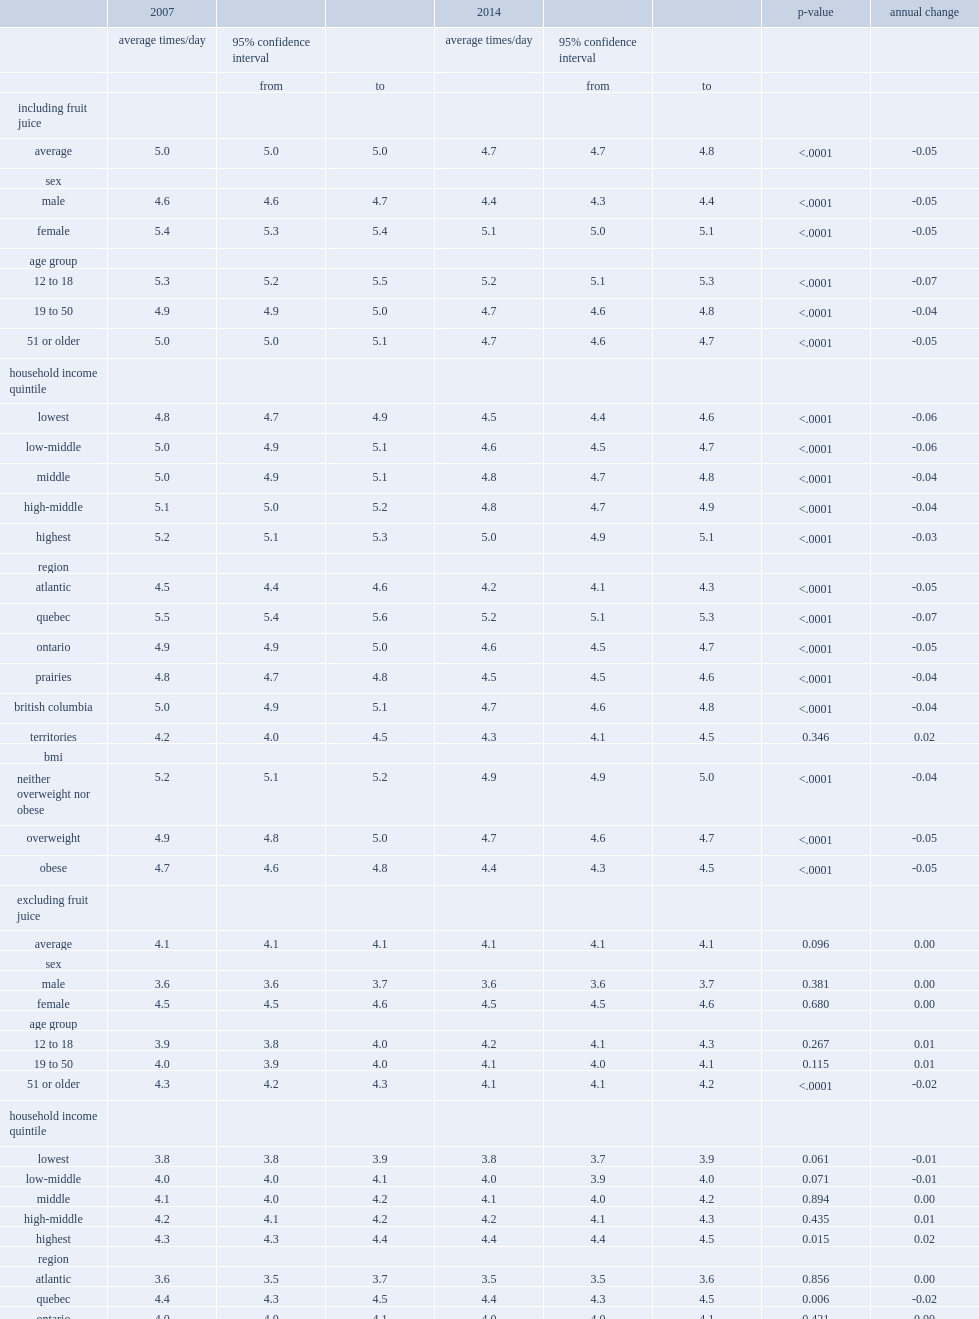What is the annual decrease in consumption frequency among both males and females? 0.05. What are the annual decreases among people in the neither overweight nor obese bmi category? 0.04. What are the annual decreases in the overweight and obese categories? 0.05 0.05. Excluding fruit juice, which group of people has a lower average frequency of fruit and vegetable consumption in both 2007 and 2014, male or female? Male. Which region has the highest fequency of consumption in both 2007 and 2014? Quebec. 